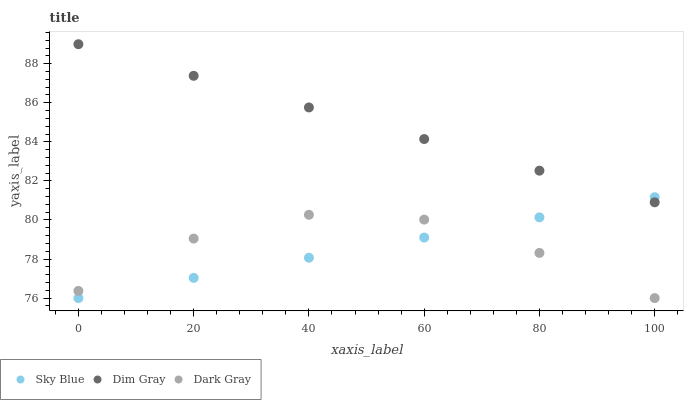Does Sky Blue have the minimum area under the curve?
Answer yes or no. Yes. Does Dim Gray have the maximum area under the curve?
Answer yes or no. Yes. Does Dim Gray have the minimum area under the curve?
Answer yes or no. No. Does Sky Blue have the maximum area under the curve?
Answer yes or no. No. Is Sky Blue the smoothest?
Answer yes or no. Yes. Is Dark Gray the roughest?
Answer yes or no. Yes. Is Dim Gray the roughest?
Answer yes or no. No. Does Dark Gray have the lowest value?
Answer yes or no. Yes. Does Dim Gray have the lowest value?
Answer yes or no. No. Does Dim Gray have the highest value?
Answer yes or no. Yes. Does Sky Blue have the highest value?
Answer yes or no. No. Is Dark Gray less than Dim Gray?
Answer yes or no. Yes. Is Dim Gray greater than Dark Gray?
Answer yes or no. Yes. Does Dim Gray intersect Sky Blue?
Answer yes or no. Yes. Is Dim Gray less than Sky Blue?
Answer yes or no. No. Is Dim Gray greater than Sky Blue?
Answer yes or no. No. Does Dark Gray intersect Dim Gray?
Answer yes or no. No. 